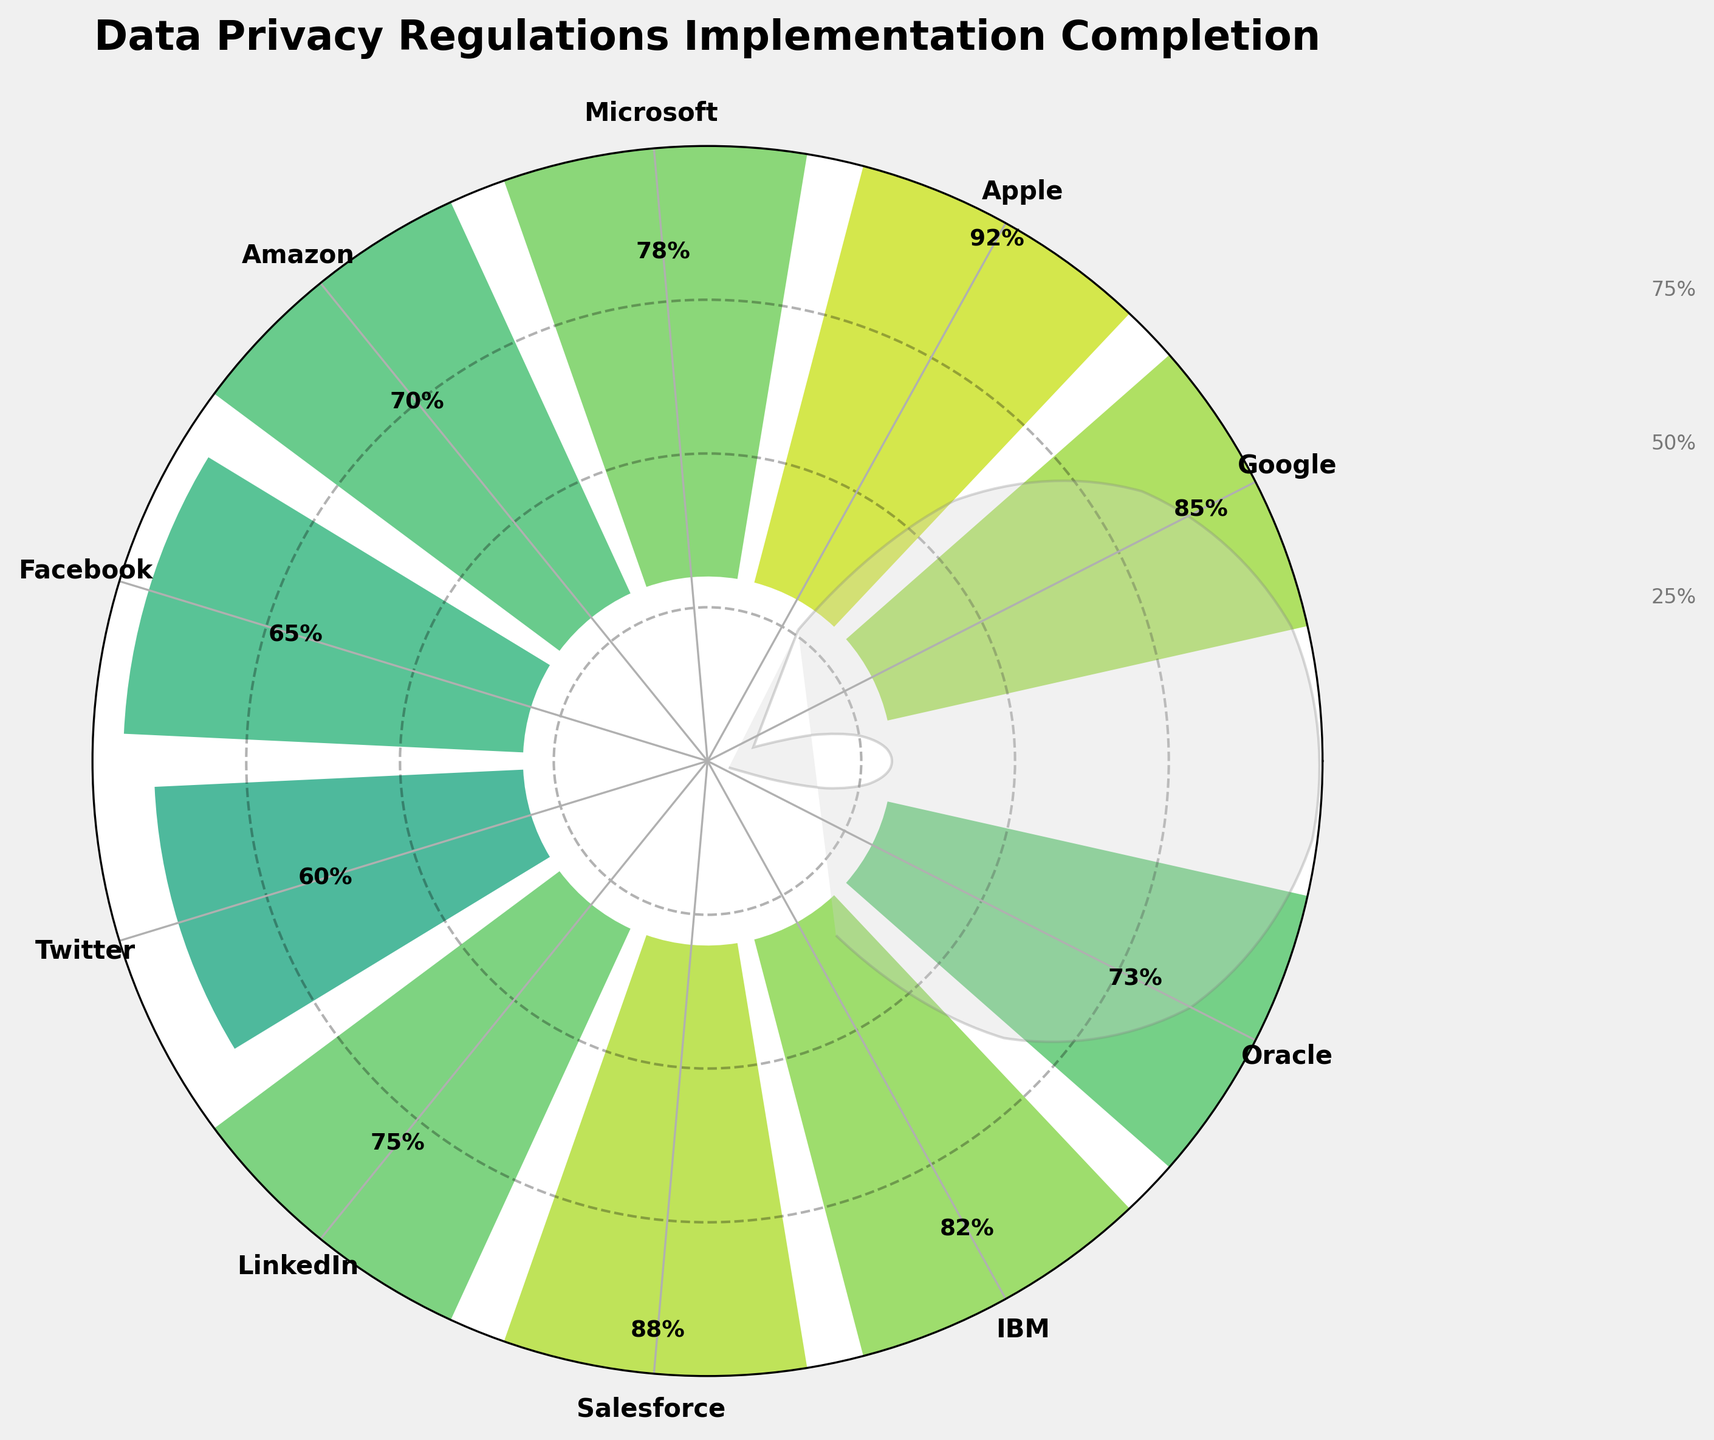What is the title of the figure? The title is generally located at the top of the figure. Looking at the placement above the polar chart and its boldness, the title states the subject of the figure.
Answer: Data Privacy Regulations Implementation Completion Which company has the highest completion percentage? To find the highest completion percentage, look at the labeled bars and the values next to them. Apple has a bar extending the farthest and a label of 92%.
Answer: Apple What is the average completion percentage of the companies represented? To calculate the average completion percentage, sum all the percentages and divide by the number of companies: (85 + 92 + 78 + 70 + 65 + 60 + 75 + 88 + 82 + 73) / 10. This equals 76.8%
Answer: 76.8% Which company has a lower completion percentage, Twitter or Facebook? Compare the lengths of the bars and the labeled values next to them. Twitter has 60% and Facebook has 65%, so Twitter has a lower percentage.
Answer: Twitter How many companies have a completion percentage higher than 80%? Identify the bars that surpass the 80% mark. They are Google (85), Apple (92), Salesforce (88), and IBM (82). Count these companies.
Answer: 4 What is the median completion percentage of the companies shown? Organize the completion percentages in ascending order: [60, 65, 70, 73, 75, 78, 82, 85, 88, 92]. The median value is the average of the 5th and 6th values in this sorted list: (75 + 78) / 2.
Answer: 76.5 Which company has the least completion percentage for data privacy regulations? Compare all the bar lengths to determine the shortest one. Twitter has the smallest bar labeled 60%.
Answer: Twitter What is the difference in completion percentage between Google and Microsoft? Look at the labeled values next to the bars for Google and Microsoft. The difference is calculated as 85% (Google) - 78% (Microsoft).
Answer: 7% Which companies have a completion percentage between 70% and 80%? Identify the bars and labels indicating values within the 70% to 80% range. These companies are Microsoft (78), Amazon (70), LinkedIn (75), and Oracle (73).
Answer: Microsoft, Amazon, LinkedIn, Oracle What is the visual appearance of the gauge-like background ring? Describe the distinctive element seen in the background of the polar chart: It's a wedge covering almost the entire polar area, filled with light gray color, and has an alpha transparency making it semi-transparent.
Answer: Light gray, semi-transparent wedge 